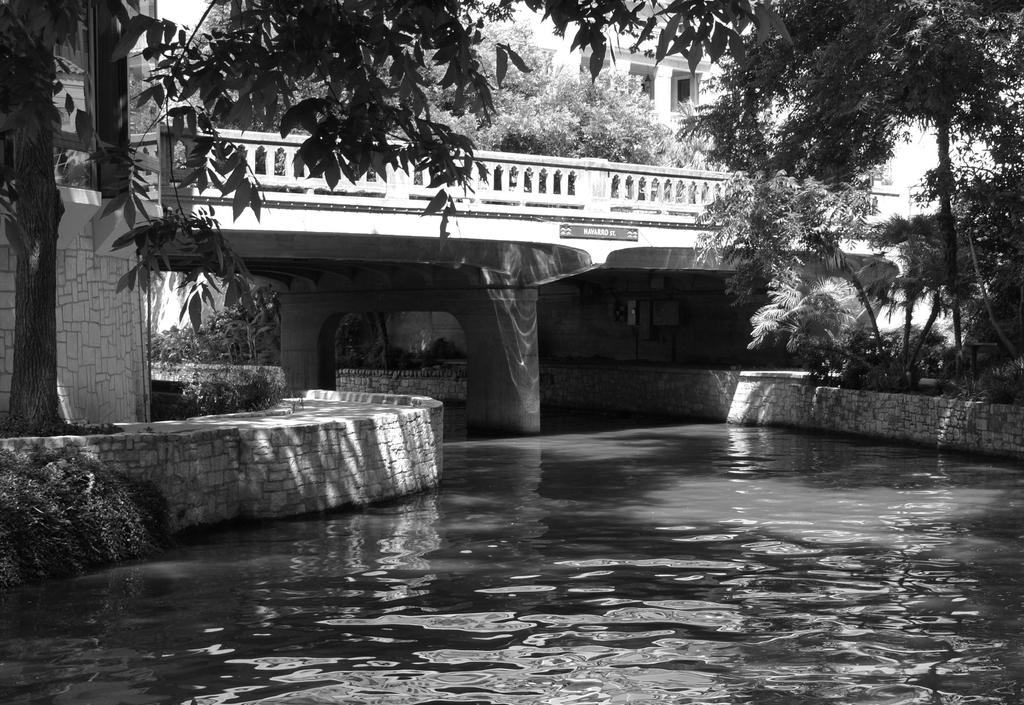What is the color scheme of the image? The image is black and white. What natural element can be seen in the image? There is water visible in the image. What type of structures are present in the image? There are walls and buildings in the image. What type of vegetation is present in the image? Shrubs and trees are visible in the image. What type of locket is hanging from the tree in the image? There is no locket present in the image; it is a black and white image featuring water, walls, buildings, shrubs, and trees. 